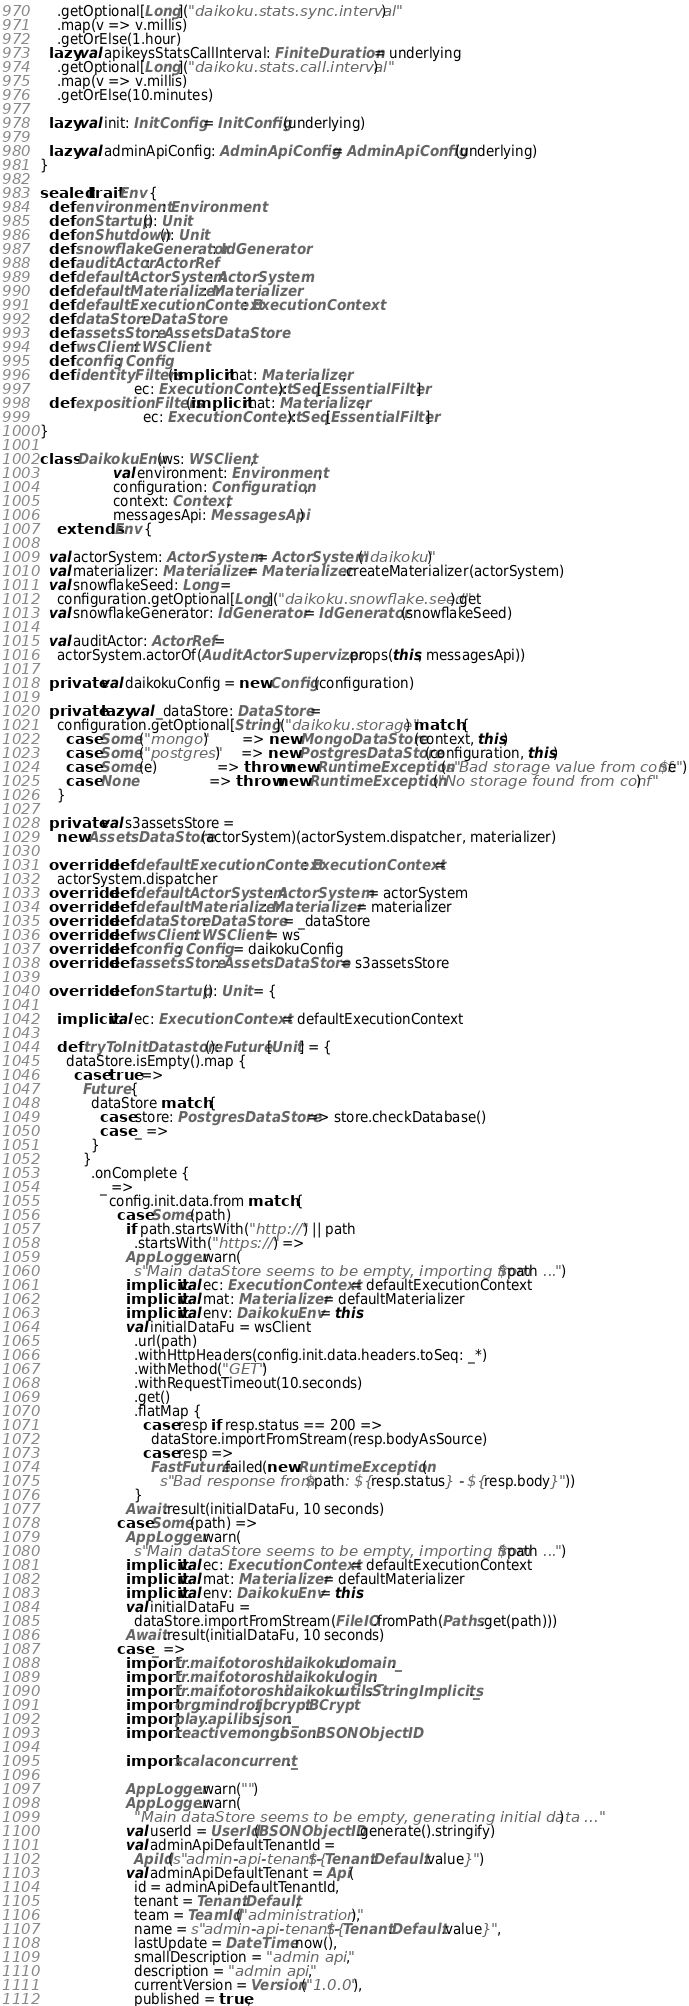<code> <loc_0><loc_0><loc_500><loc_500><_Scala_>    .getOptional[Long]("daikoku.stats.sync.interval")
    .map(v => v.millis)
    .getOrElse(1.hour)
  lazy val apikeysStatsCallInterval: FiniteDuration = underlying
    .getOptional[Long]("daikoku.stats.call.interval")
    .map(v => v.millis)
    .getOrElse(10.minutes)

  lazy val init: InitConfig = InitConfig(underlying)

  lazy val adminApiConfig: AdminApiConfig = AdminApiConfig(underlying)
}

sealed trait Env {
  def environment: Environment
  def onStartup(): Unit
  def onShutdown(): Unit
  def snowflakeGenerator: IdGenerator
  def auditActor: ActorRef
  def defaultActorSystem: ActorSystem
  def defaultMaterializer: Materializer
  def defaultExecutionContext: ExecutionContext
  def dataStore: DataStore
  def assetsStore: AssetsDataStore
  def wsClient: WSClient
  def config: Config
  def identityFilters(implicit mat: Materializer,
                      ec: ExecutionContext): Seq[EssentialFilter]
  def expositionFilters(implicit mat: Materializer,
                        ec: ExecutionContext): Seq[EssentialFilter]
}

class DaikokuEnv(ws: WSClient,
                 val environment: Environment,
                 configuration: Configuration,
                 context: Context,
                 messagesApi: MessagesApi)
    extends Env {

  val actorSystem: ActorSystem = ActorSystem("daikoku")
  val materializer: Materializer = Materializer.createMaterializer(actorSystem)
  val snowflakeSeed: Long =
    configuration.getOptional[Long]("daikoku.snowflake.seed").get
  val snowflakeGenerator: IdGenerator = IdGenerator(snowflakeSeed)

  val auditActor: ActorRef =
    actorSystem.actorOf(AuditActorSupervizer.props(this, messagesApi))

  private val daikokuConfig = new Config(configuration)

  private lazy val _dataStore: DataStore =
    configuration.getOptional[String]("daikoku.storage") match {
      case Some("mongo")        => new MongoDataStore(context, this)
      case Some("postgres")     => new PostgresDataStore(configuration, this)
      case Some(e)              => throw new RuntimeException(s"Bad storage value from conf: $e")
      case None                 => throw new RuntimeException("No storage found from conf")
    }

  private val s3assetsStore =
    new AssetsDataStore(actorSystem)(actorSystem.dispatcher, materializer)

  override def defaultExecutionContext: ExecutionContext =
    actorSystem.dispatcher
  override def defaultActorSystem: ActorSystem = actorSystem
  override def defaultMaterializer: Materializer = materializer
  override def dataStore: DataStore = _dataStore
  override def wsClient: WSClient = ws
  override def config: Config = daikokuConfig
  override def assetsStore: AssetsDataStore = s3assetsStore

  override def onStartup(): Unit = {

    implicit val ec: ExecutionContext = defaultExecutionContext

    def tryToInitDatastore(): Future[Unit] = {
      dataStore.isEmpty().map {
        case true =>
          Future {
            dataStore match {
              case store: PostgresDataStore => store.checkDatabase()
              case _ =>
            }
          }
            .onComplete {
              _ =>
                config.init.data.from match {
                  case Some(path)
                    if path.startsWith("http://") || path
                      .startsWith("https://") =>
                    AppLogger.warn(
                      s"Main dataStore seems to be empty, importing from $path ...")
                    implicit val ec: ExecutionContext = defaultExecutionContext
                    implicit val mat: Materializer = defaultMaterializer
                    implicit val env: DaikokuEnv = this
                    val initialDataFu = wsClient
                      .url(path)
                      .withHttpHeaders(config.init.data.headers.toSeq: _*)
                      .withMethod("GET")
                      .withRequestTimeout(10.seconds)
                      .get()
                      .flatMap {
                        case resp if resp.status == 200 =>
                          dataStore.importFromStream(resp.bodyAsSource)
                        case resp =>
                          FastFuture.failed(new RuntimeException(
                            s"Bad response from $path: ${resp.status} - ${resp.body}"))
                      }
                    Await.result(initialDataFu, 10 seconds)
                  case Some(path) =>
                    AppLogger.warn(
                      s"Main dataStore seems to be empty, importing from $path ...")
                    implicit val ec: ExecutionContext = defaultExecutionContext
                    implicit val mat: Materializer = defaultMaterializer
                    implicit val env: DaikokuEnv = this
                    val initialDataFu =
                      dataStore.importFromStream(FileIO.fromPath(Paths.get(path)))
                    Await.result(initialDataFu, 10 seconds)
                  case _ =>
                    import fr.maif.otoroshi.daikoku.domain._
                    import fr.maif.otoroshi.daikoku.login._
                    import fr.maif.otoroshi.daikoku.utils.StringImplicits._
                    import org.mindrot.jbcrypt.BCrypt
                    import play.api.libs.json._
                    import reactivemongo.bson.BSONObjectID

                    import scala.concurrent._

                    AppLogger.warn("")
                    AppLogger.warn(
                      "Main dataStore seems to be empty, generating initial data ...")
                    val userId = UserId(BSONObjectID.generate().stringify)
                    val adminApiDefaultTenantId =
                      ApiId(s"admin-api-tenant-${Tenant.Default.value}")
                    val adminApiDefaultTenant = Api(
                      id = adminApiDefaultTenantId,
                      tenant = Tenant.Default,
                      team = TeamId("administration"),
                      name = s"admin-api-tenant-${Tenant.Default.value}",
                      lastUpdate = DateTime.now(),
                      smallDescription = "admin api",
                      description = "admin api",
                      currentVersion = Version("1.0.0"),
                      published = true,</code> 